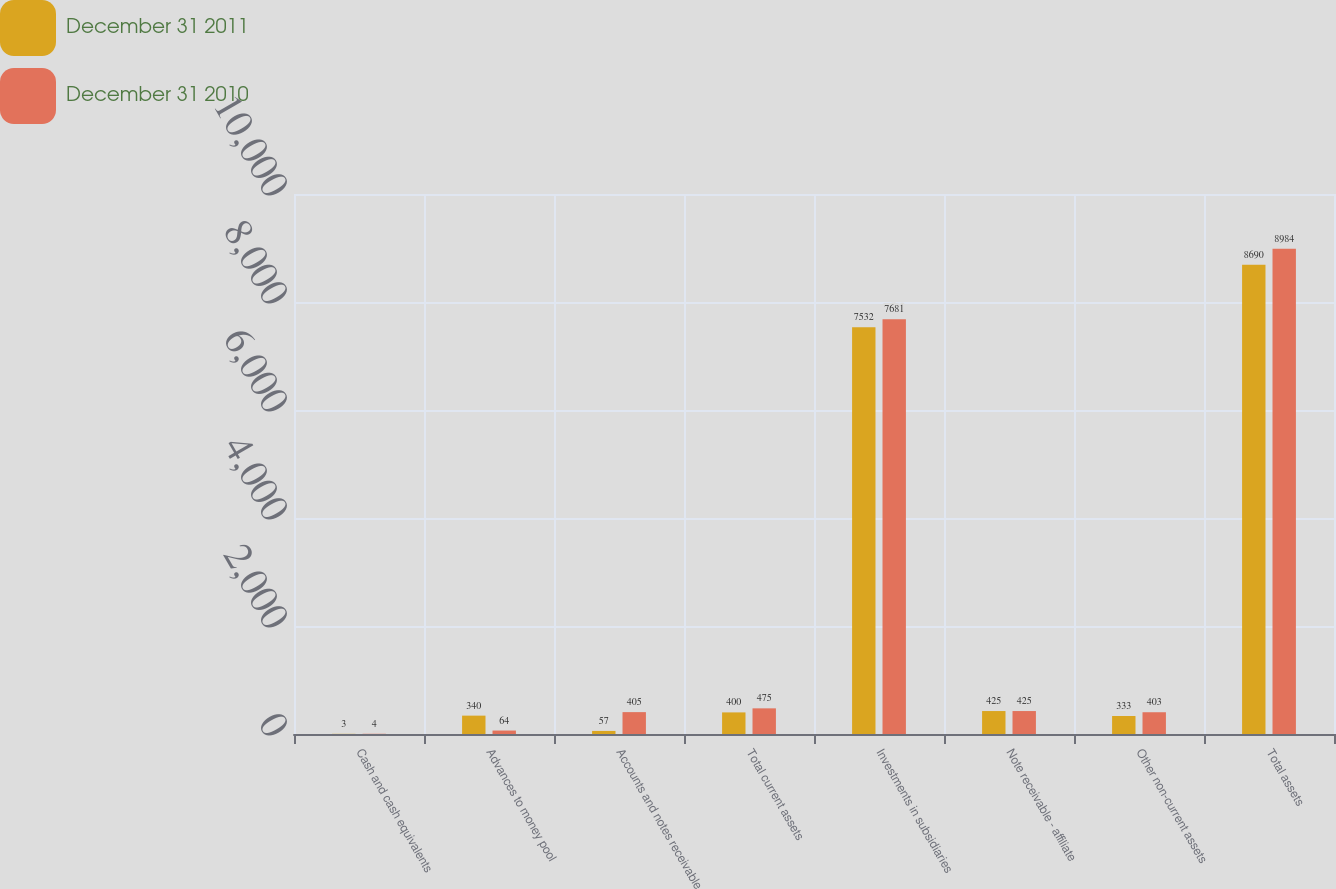<chart> <loc_0><loc_0><loc_500><loc_500><stacked_bar_chart><ecel><fcel>Cash and cash equivalents<fcel>Advances to money pool<fcel>Accounts and notes receivable<fcel>Total current assets<fcel>Investments in subsidiaries<fcel>Note receivable - affiliate<fcel>Other non-current assets<fcel>Total assets<nl><fcel>December 31 2011<fcel>3<fcel>340<fcel>57<fcel>400<fcel>7532<fcel>425<fcel>333<fcel>8690<nl><fcel>December 31 2010<fcel>4<fcel>64<fcel>405<fcel>475<fcel>7681<fcel>425<fcel>403<fcel>8984<nl></chart> 